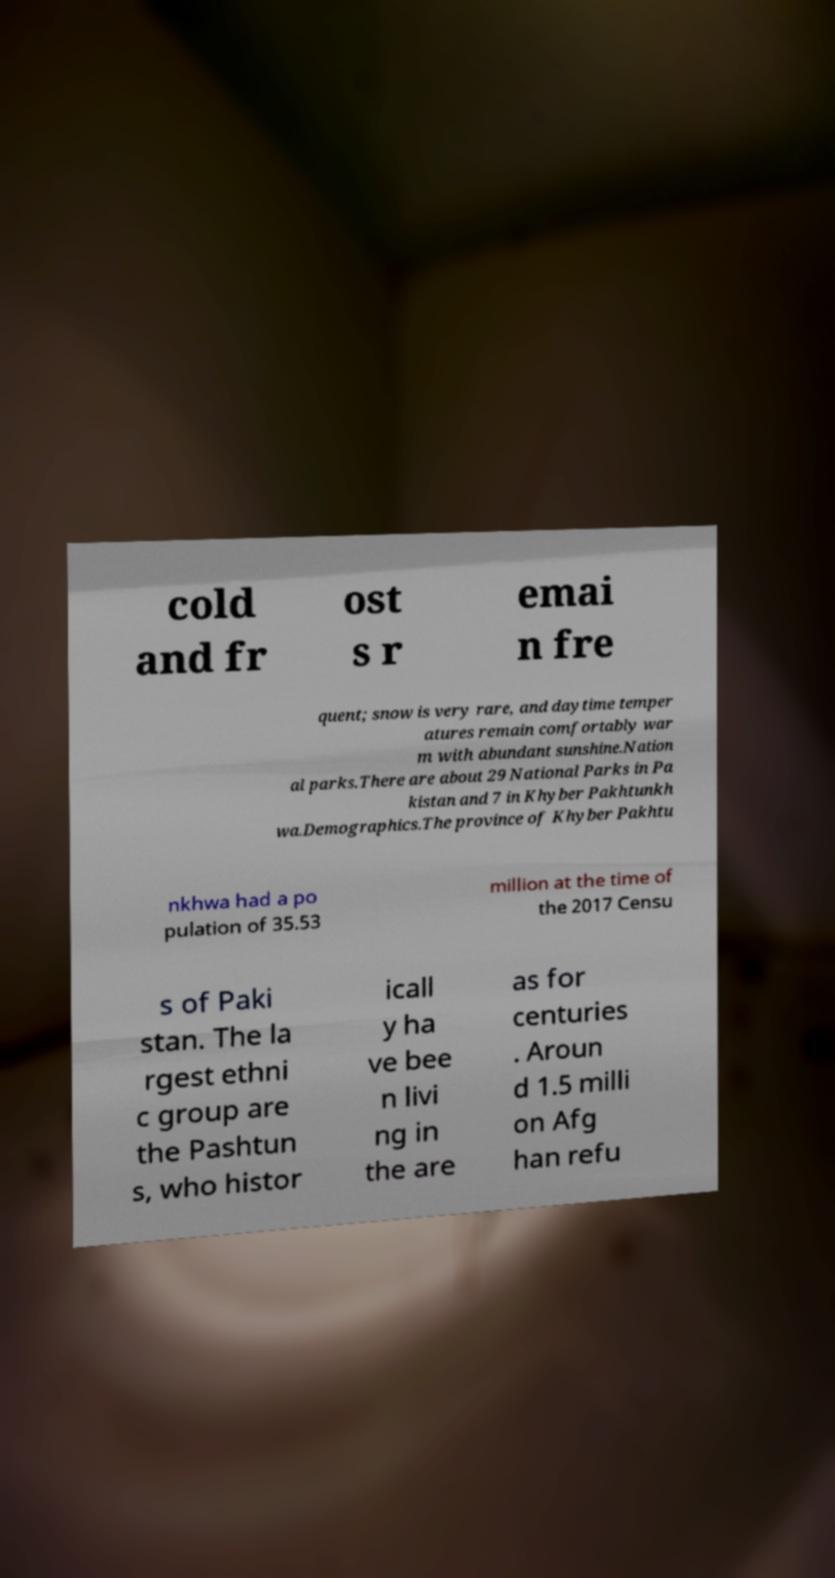What messages or text are displayed in this image? I need them in a readable, typed format. cold and fr ost s r emai n fre quent; snow is very rare, and daytime temper atures remain comfortably war m with abundant sunshine.Nation al parks.There are about 29 National Parks in Pa kistan and 7 in Khyber Pakhtunkh wa.Demographics.The province of Khyber Pakhtu nkhwa had a po pulation of 35.53 million at the time of the 2017 Censu s of Paki stan. The la rgest ethni c group are the Pashtun s, who histor icall y ha ve bee n livi ng in the are as for centuries . Aroun d 1.5 milli on Afg han refu 